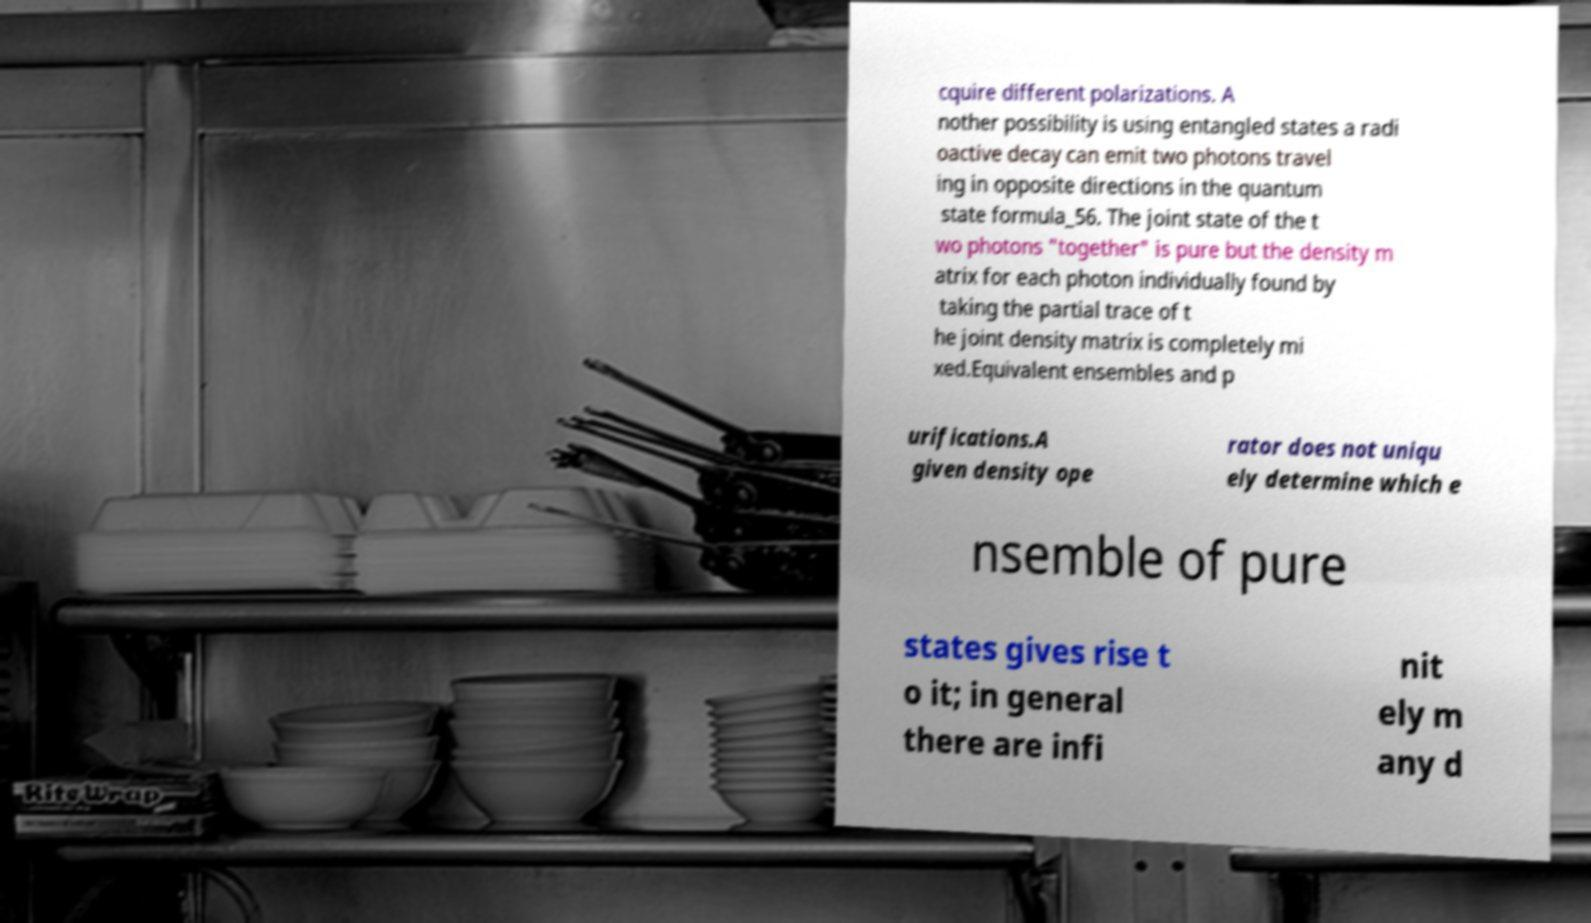Can you accurately transcribe the text from the provided image for me? cquire different polarizations. A nother possibility is using entangled states a radi oactive decay can emit two photons travel ing in opposite directions in the quantum state formula_56. The joint state of the t wo photons "together" is pure but the density m atrix for each photon individually found by taking the partial trace of t he joint density matrix is completely mi xed.Equivalent ensembles and p urifications.A given density ope rator does not uniqu ely determine which e nsemble of pure states gives rise t o it; in general there are infi nit ely m any d 